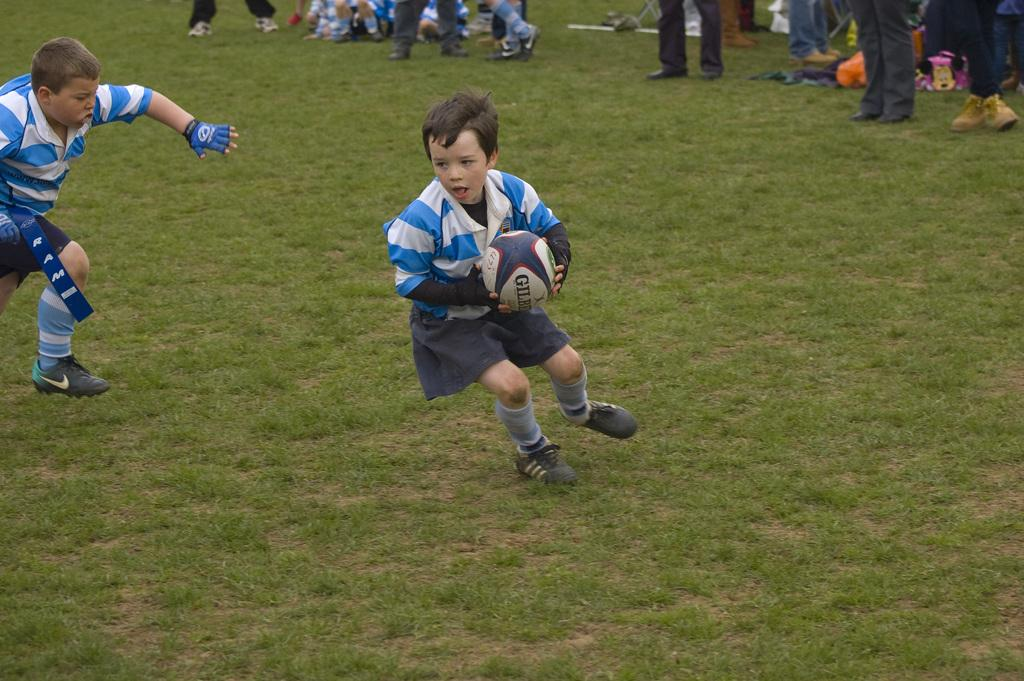Where was the image taken? The image was taken in a ground. Can you describe the people on the top in the image? There are people on the top, but their specific actions or characteristics are not mentioned in the facts. What are the two kids doing in the image? The two kids are playing a game in the image. What object is one of the kids holding? One of the kids is holding a ball in his hands. What type of property is being discussed in the image? There is no mention of any property in the image. Can you tell me how many trains are visible in the image? There are no trains present in the image. 